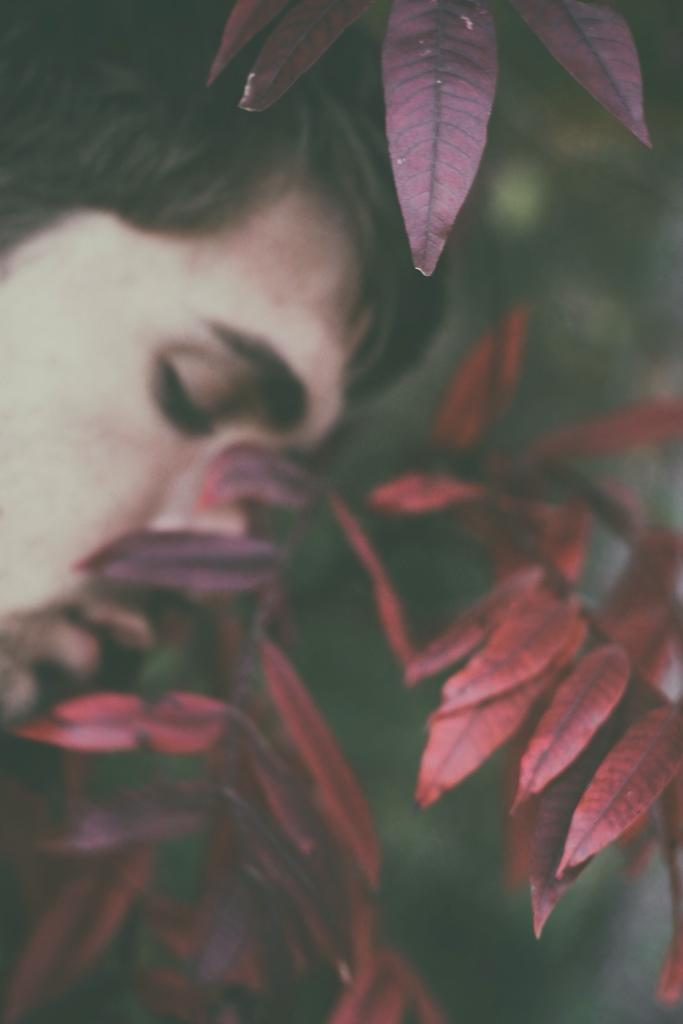Who or what is on the left side of the image? There is a person on the left side of the image. What can be seen on the right side of the image? There are leaves on the right side of the image. What type of toys can be seen in the hospital room in the image? There is no hospital or toys present in the image; it only features a person and leaves. 